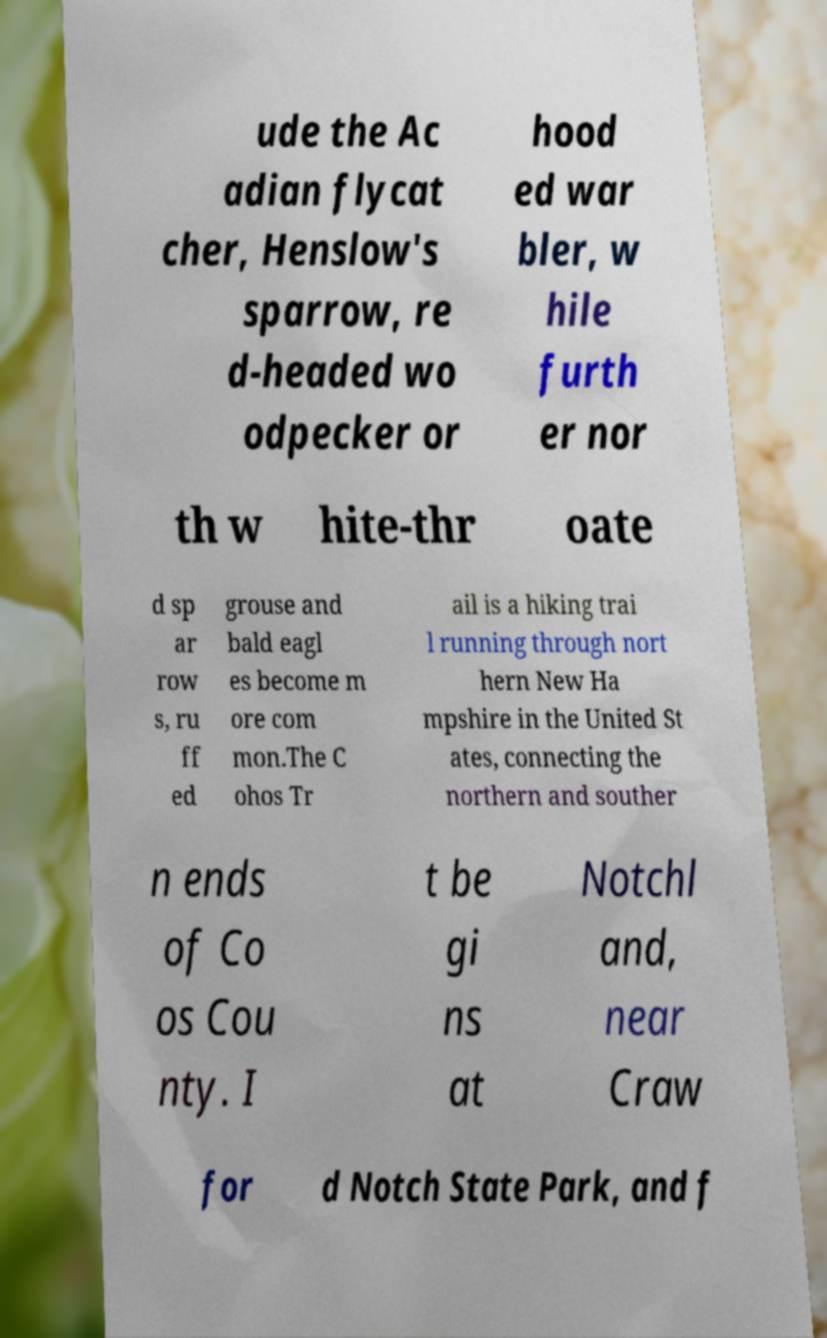Please read and relay the text visible in this image. What does it say? ude the Ac adian flycat cher, Henslow's sparrow, re d-headed wo odpecker or hood ed war bler, w hile furth er nor th w hite-thr oate d sp ar row s, ru ff ed grouse and bald eagl es become m ore com mon.The C ohos Tr ail is a hiking trai l running through nort hern New Ha mpshire in the United St ates, connecting the northern and souther n ends of Co os Cou nty. I t be gi ns at Notchl and, near Craw for d Notch State Park, and f 